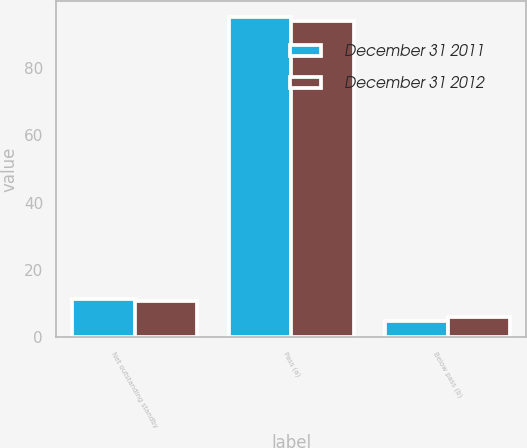Convert chart. <chart><loc_0><loc_0><loc_500><loc_500><stacked_bar_chart><ecel><fcel>Net outstanding standby<fcel>Pass (a)<fcel>Below pass (b)<nl><fcel>December 31 2011<fcel>11.5<fcel>95<fcel>5<nl><fcel>December 31 2012<fcel>10.8<fcel>94<fcel>6<nl></chart> 